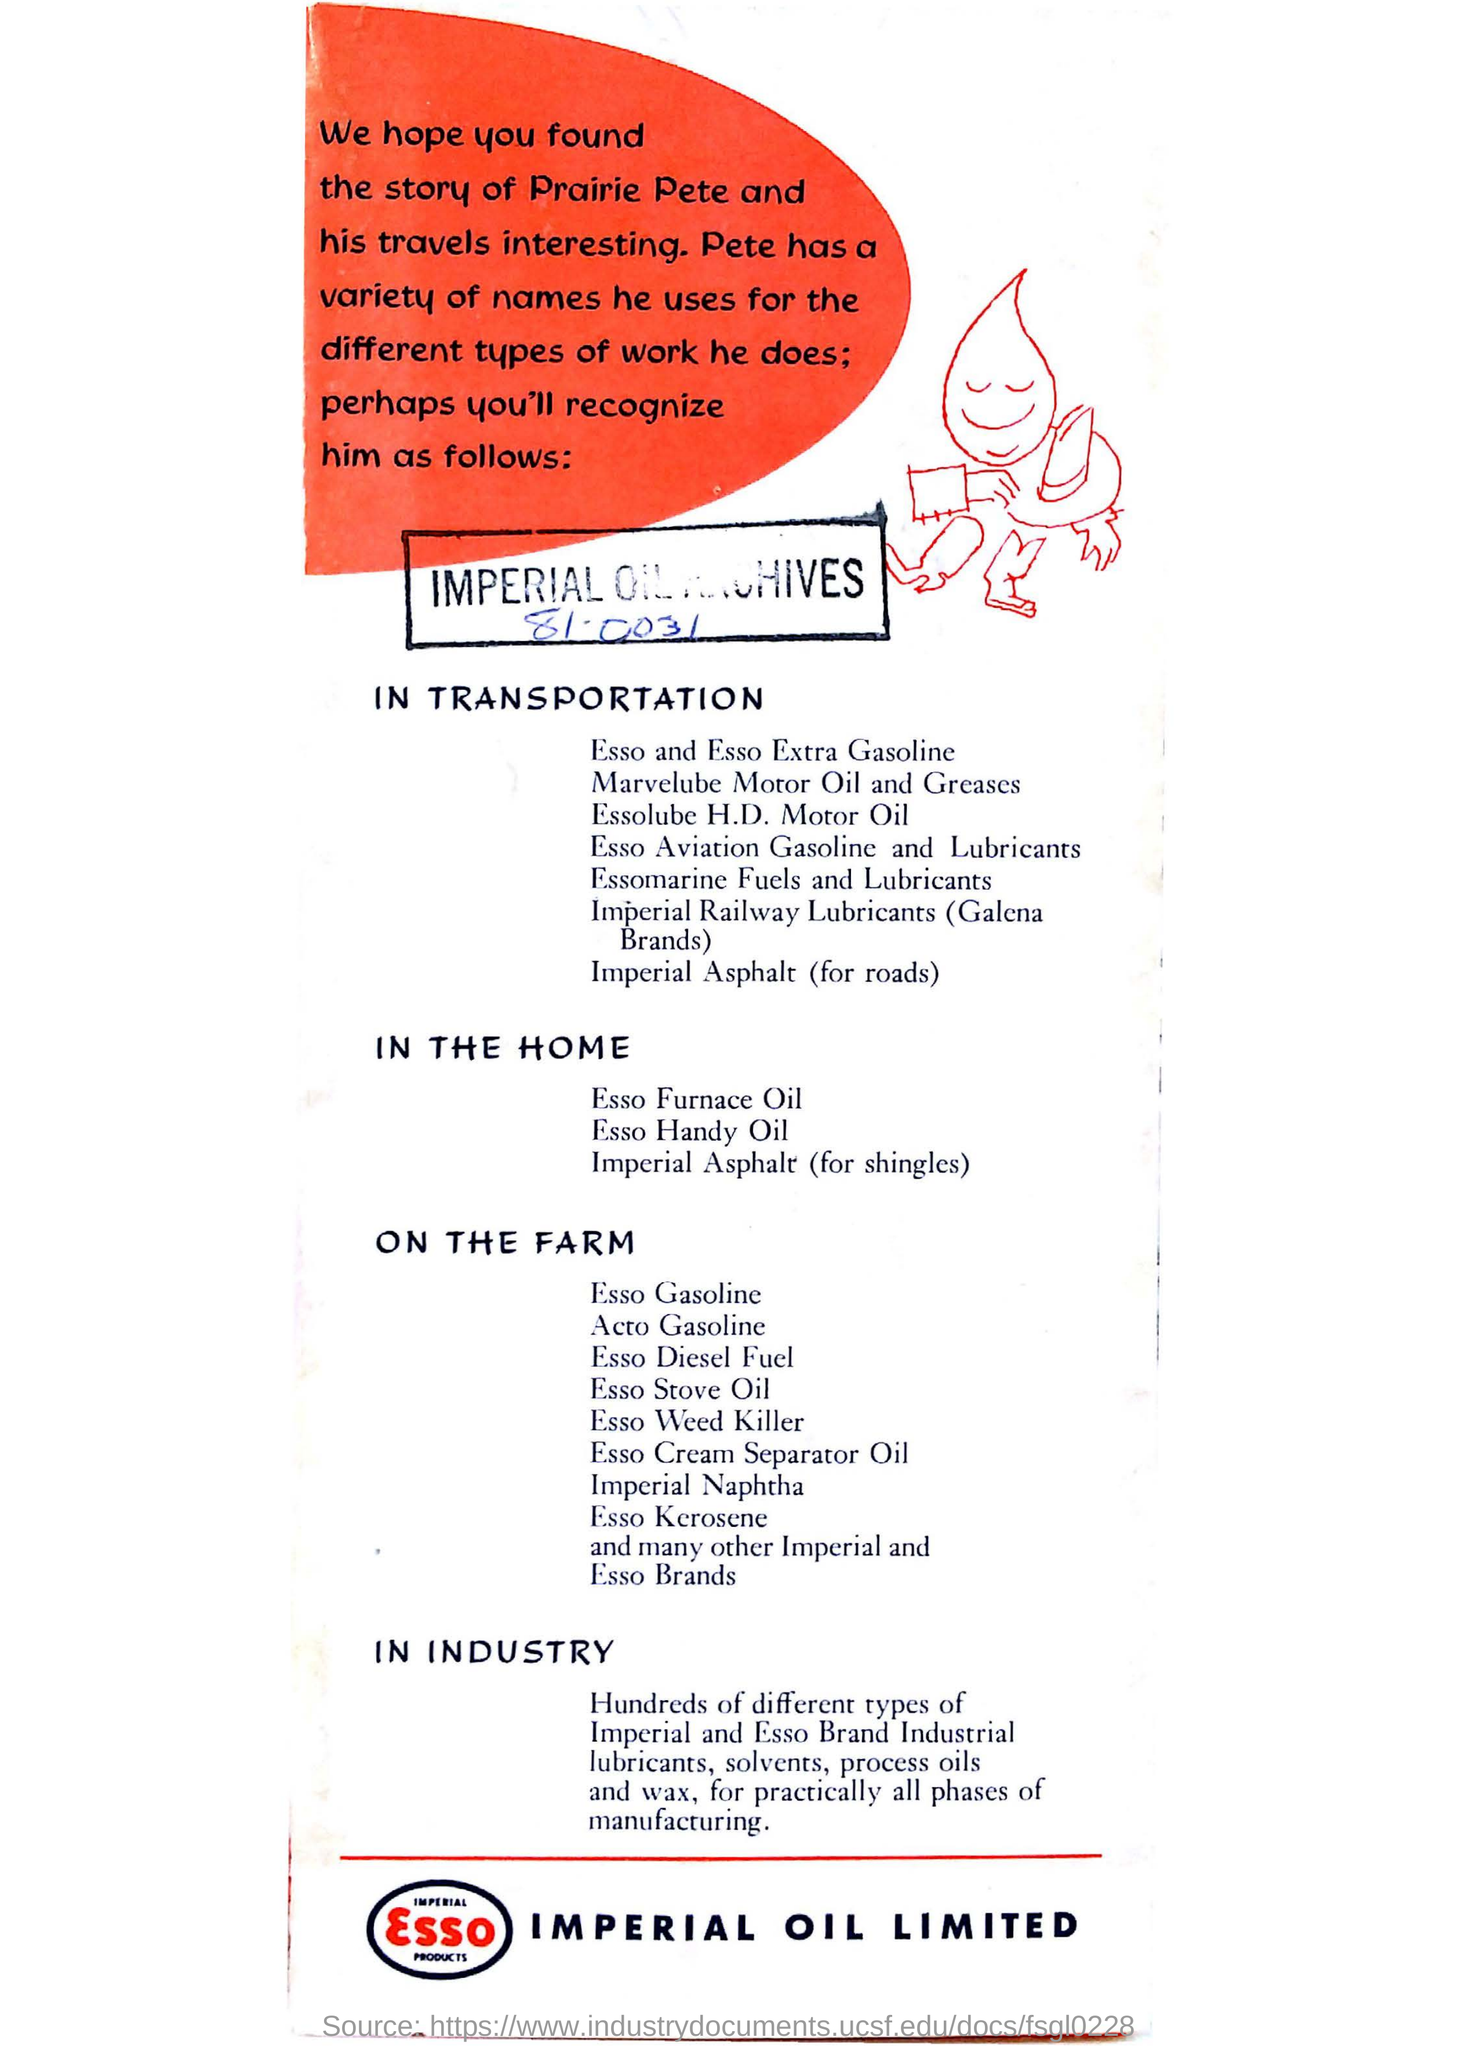Specify some key components in this picture. This advertisement belongs to Imperial Oil Limited. 